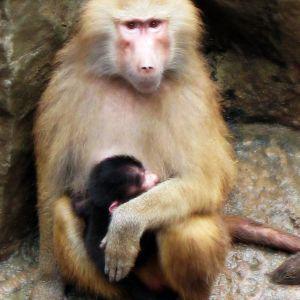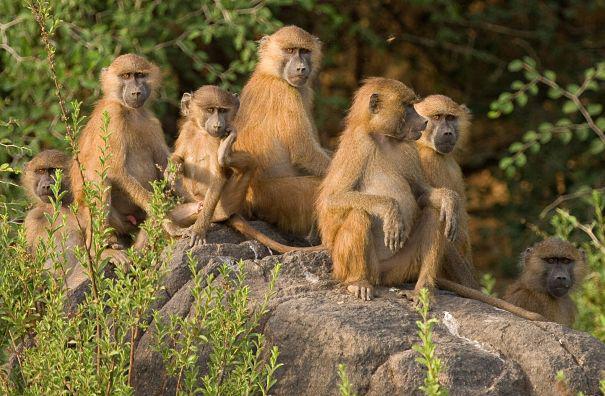The first image is the image on the left, the second image is the image on the right. Considering the images on both sides, is "No monkey is photographed alone." valid? Answer yes or no. Yes. 